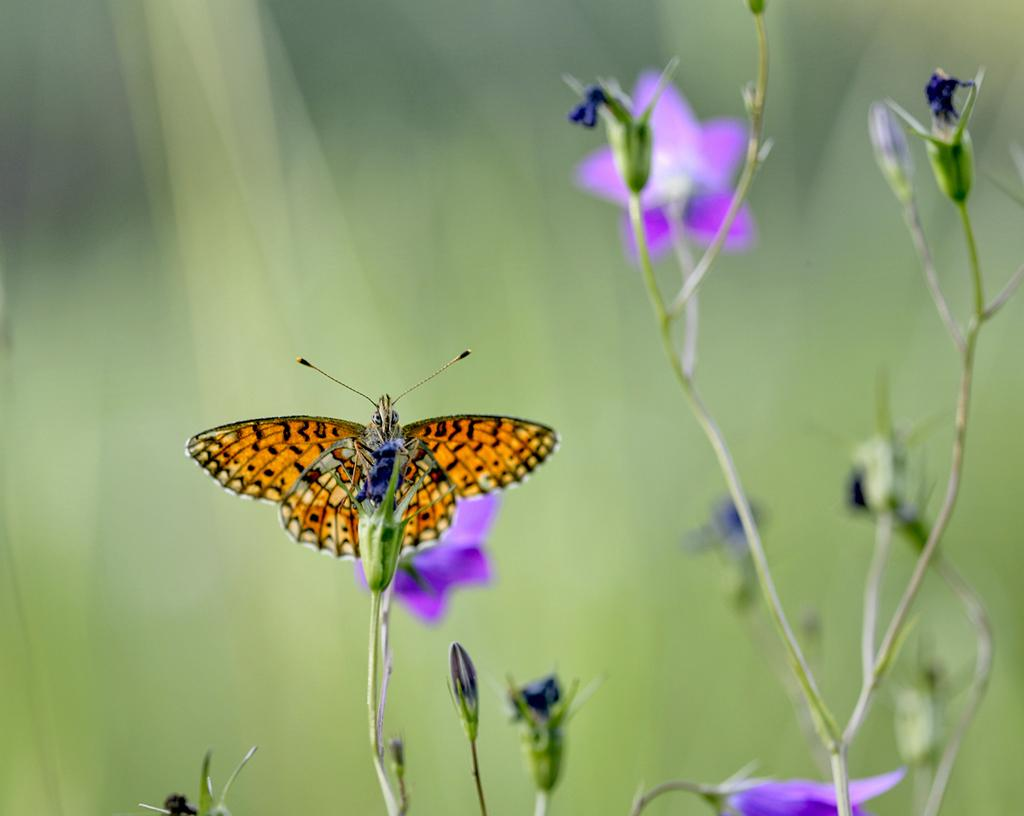What is the main subject of the image? There is a butterfly in the image. Where is the butterfly located in the image? The butterfly is on a flower. What type of account does the butterfly have in the image? There is no mention of an account in the image, as it features a butterfly on a flower. What material is the brass used for in the image? There is no brass present in the image. 